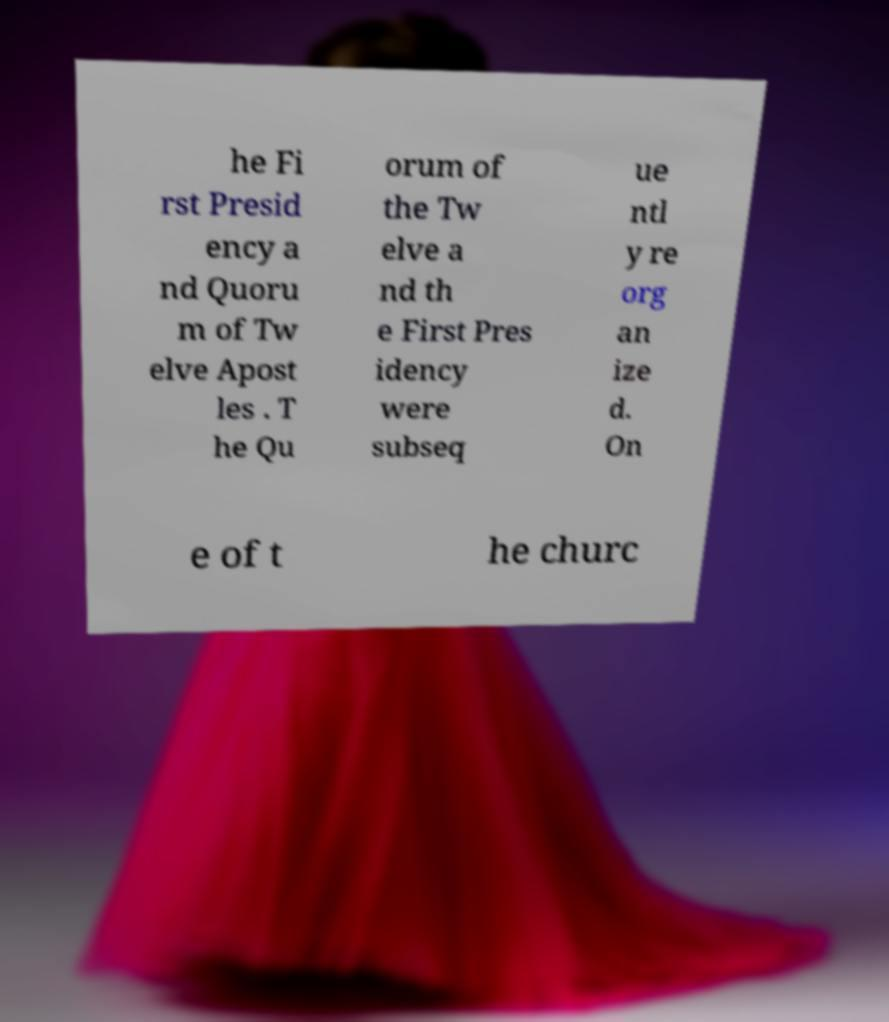Can you read and provide the text displayed in the image?This photo seems to have some interesting text. Can you extract and type it out for me? he Fi rst Presid ency a nd Quoru m of Tw elve Apost les . T he Qu orum of the Tw elve a nd th e First Pres idency were subseq ue ntl y re org an ize d. On e of t he churc 